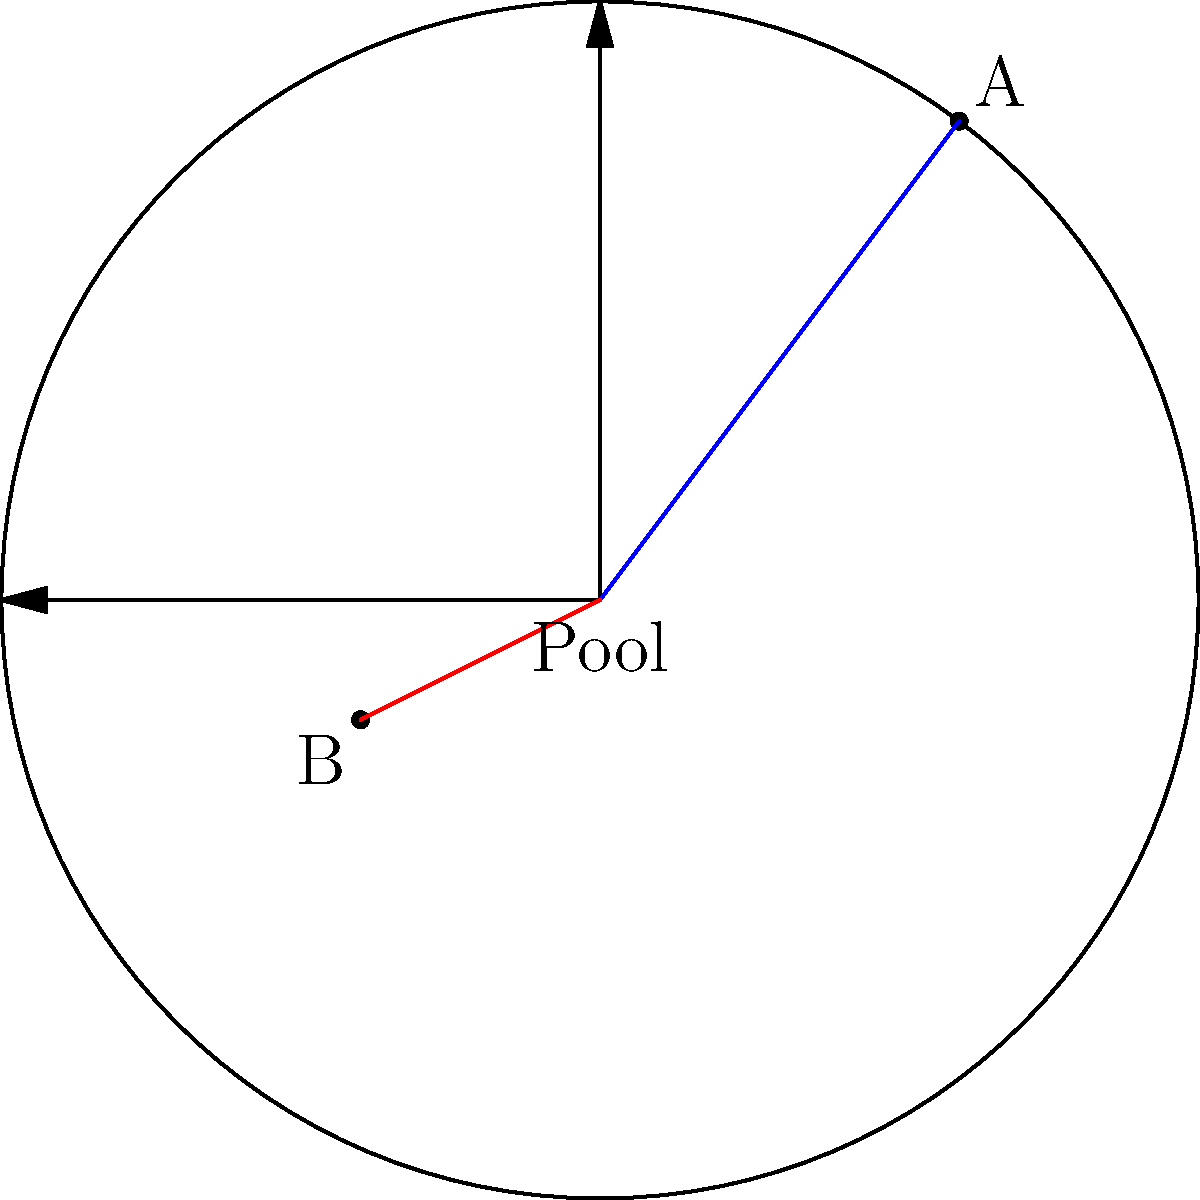In a water polo match, player A is positioned at (3,4) and player B at (-2,-1) in the pool, with coordinates given in meters relative to the center. Calculate the distance between the two players and the angle (in degrees) that the line connecting them makes with the positive x-axis. To solve this problem, we'll use polar coordinates and vector operations:

1. Convert both positions to vectors:
   $\vec{A} = (3,4)$ and $\vec{B} = (-2,-1)$

2. Calculate the vector from B to A:
   $\vec{BA} = \vec{A} - \vec{B} = (3,4) - (-2,-1) = (5,5)$

3. Calculate the distance (magnitude of $\vec{BA}$):
   $d = \sqrt{5^2 + 5^2} = 5\sqrt{2} \approx 7.07$ meters

4. Calculate the angle using the arctangent function:
   $\theta = \arctan(\frac{y}{x}) = \arctan(\frac{5}{5}) = \arctan(1) = 45°$

5. Verify the quadrant:
   Since both x and y are positive, the angle is in the first quadrant, so no adjustment is needed.

Therefore, the distance between the players is $5\sqrt{2}$ meters, and the angle is 45°.
Answer: $5\sqrt{2}$ meters, 45° 